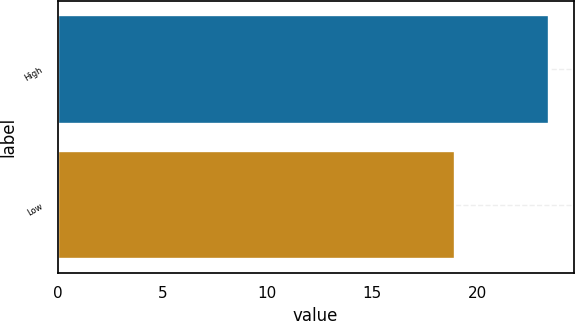<chart> <loc_0><loc_0><loc_500><loc_500><bar_chart><fcel>High<fcel>Low<nl><fcel>23.43<fcel>18.93<nl></chart> 